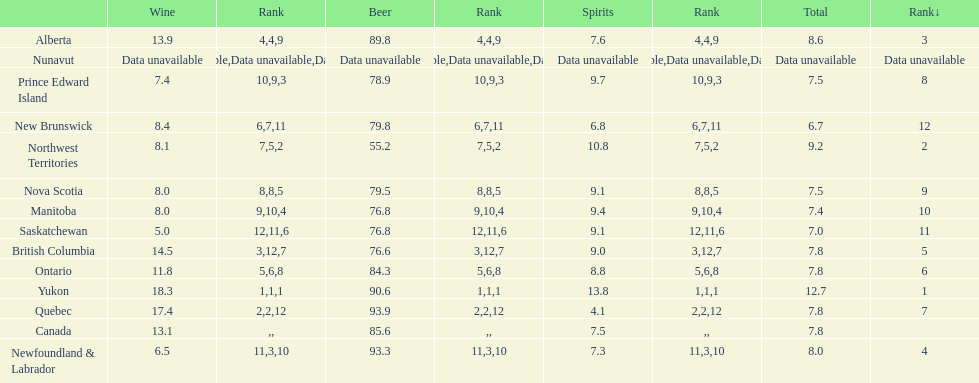What are the number of territories that have a wine consumption above 10.0? 5. 